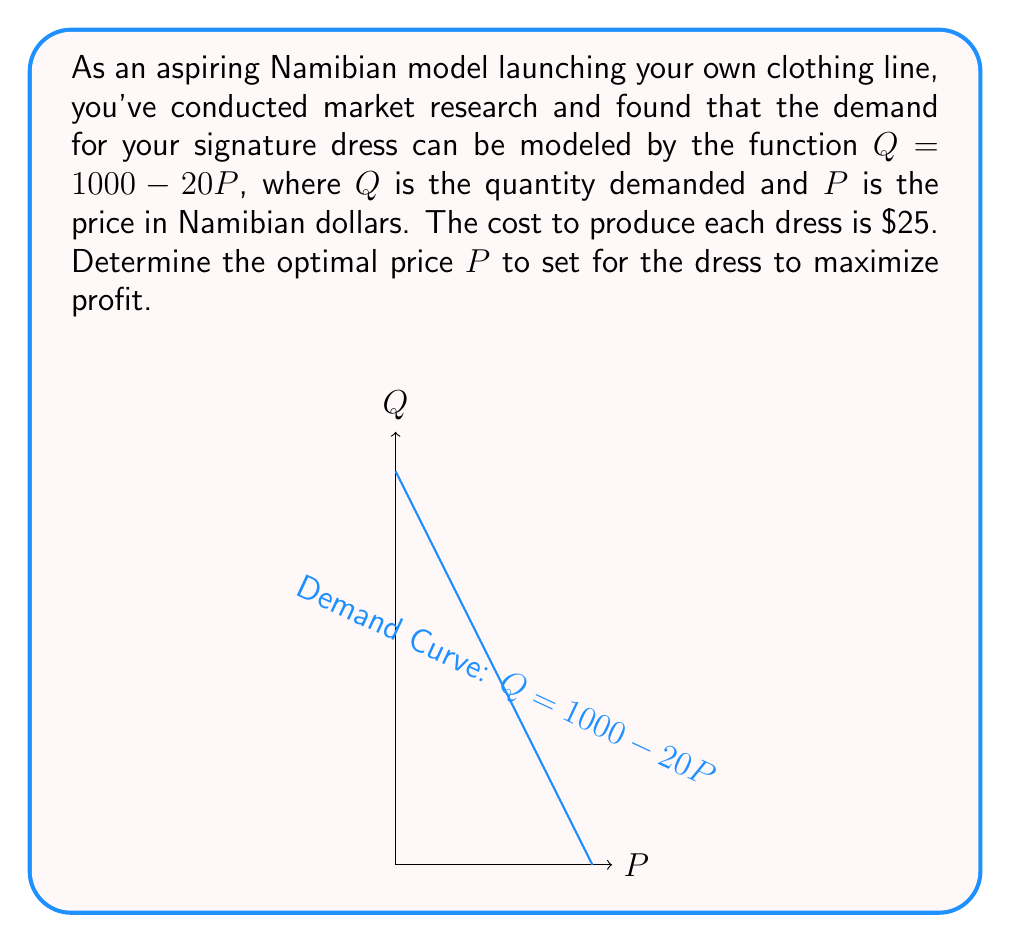Teach me how to tackle this problem. Let's approach this step-by-step:

1) First, we need to set up the profit function. Profit is revenue minus cost.

2) Revenue = Price × Quantity
   $R = P \times Q = P(1000 - 20P) = 1000P - 20P^2$

3) Cost = Cost per unit × Quantity
   $C = 25 \times Q = 25(1000 - 20P) = 25000 - 500P$

4) Profit = Revenue - Cost
   $\Pi = R - C = (1000P - 20P^2) - (25000 - 500P)$
   $\Pi = 1000P - 20P^2 - 25000 + 500P$
   $\Pi = 1500P - 20P^2 - 25000$

5) To maximize profit, we find where the derivative of the profit function equals zero:
   $\frac{d\Pi}{dP} = 1500 - 40P = 0$

6) Solving this equation:
   $1500 - 40P = 0$
   $1500 = 40P$
   $P = \frac{1500}{40} = 37.5$

7) To confirm this is a maximum, we check the second derivative:
   $\frac{d^2\Pi}{dP^2} = -40$, which is negative, confirming a maximum.

8) Therefore, the optimal price is $\$37.50$ Namibian dollars.

9) At this price, the quantity demanded will be:
   $Q = 1000 - 20(37.5) = 250$ dresses

10) The maximum profit can be calculated by plugging $P = 37.5$ into the profit function:
    $\Pi = 1500(37.5) - 20(37.5)^2 - 25000 = 3125$ Namibian dollars
Answer: $\$37.50$ Namibian dollars 